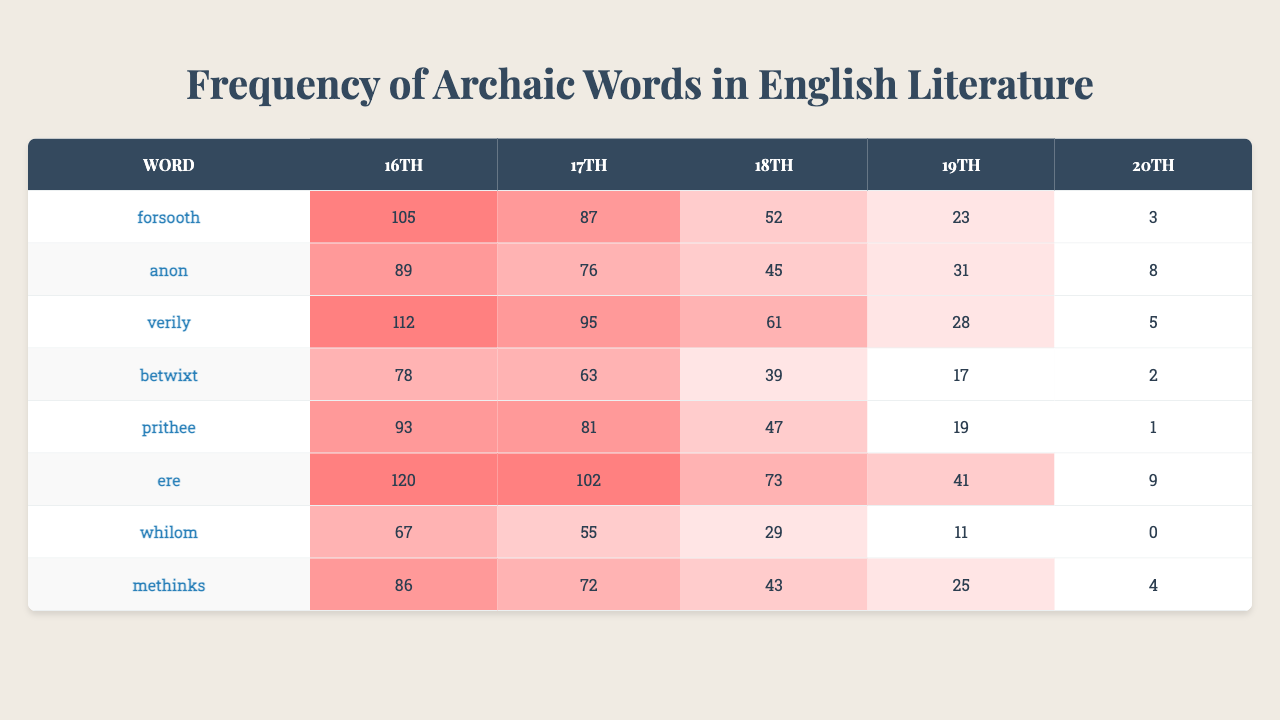What is the most frequently used archaic word in the 16th century? The table shows that "ere" has the highest frequency of occurrences in the 16th century with a frequency of 120.
Answer: ere Which archaic word saw the greatest decline in usage from the 17th to the 20th century? Comparing the frequencies from the 17th to the 20th century: "forsooth" dropped from 87 to 3, and "verily" fell from 95 to 5. Thus, "forsooth" had the greatest decline of 84.
Answer: forsooth What is the total frequency of the word "anon" across all centuries? The frequencies for "anon" are 89, 76, 45, 31, and 8. Summing these gives: 89 + 76 + 45 + 31 + 8 = 249.
Answer: 249 Which century had the highest frequency of the word "whilom"? The frequencies for "whilom" are 67, 55, 29, 11, and 0 across the centuries. The highest frequency is 67 in the 16th century.
Answer: 16th century Is the word "methinks" more common in the 18th or 19th century? The frequency of "methinks" in the 18th century is 43, while in the 19th century it is 25. Therefore, "methinks" is more common in the 18th century.
Answer: 18th century What is the average frequency of the word "betwixt" across all centuries? The frequencies for "betwixt" are 78, 63, 39, 17, and 2. Adding these gives 78 + 63 + 39 + 17 + 2 = 199. Then, dividing by 5 (the number of centuries) gives an average of 39.8.
Answer: 39.8 Which word has the lowest frequency in the 20th century? The table indicates that "whilom" has a frequency of 0 in the 20th century, making it the least used archaic word in that time period.
Answer: whilom What is the difference in frequency of the word "prithee" between the 16th and 19th centuries? The frequency of "prithee" in the 16th century is 93, and in the 19th century, it is 19. The difference is 93 - 19 = 74.
Answer: 74 How many archaic words had a frequency of over 100 in the 16th century? Looking at the frequencies in the 16th century: "ere" (120), "verily" (112), and "forsooth" (105) all exceed 100. Therefore, there are three words with a frequency over 100.
Answer: 3 Which word's frequency remained constant or increasing throughout the centuries? None of the words showed a constant or increasing frequency trend; all words displayed a decline in usage over the centuries.
Answer: No words 